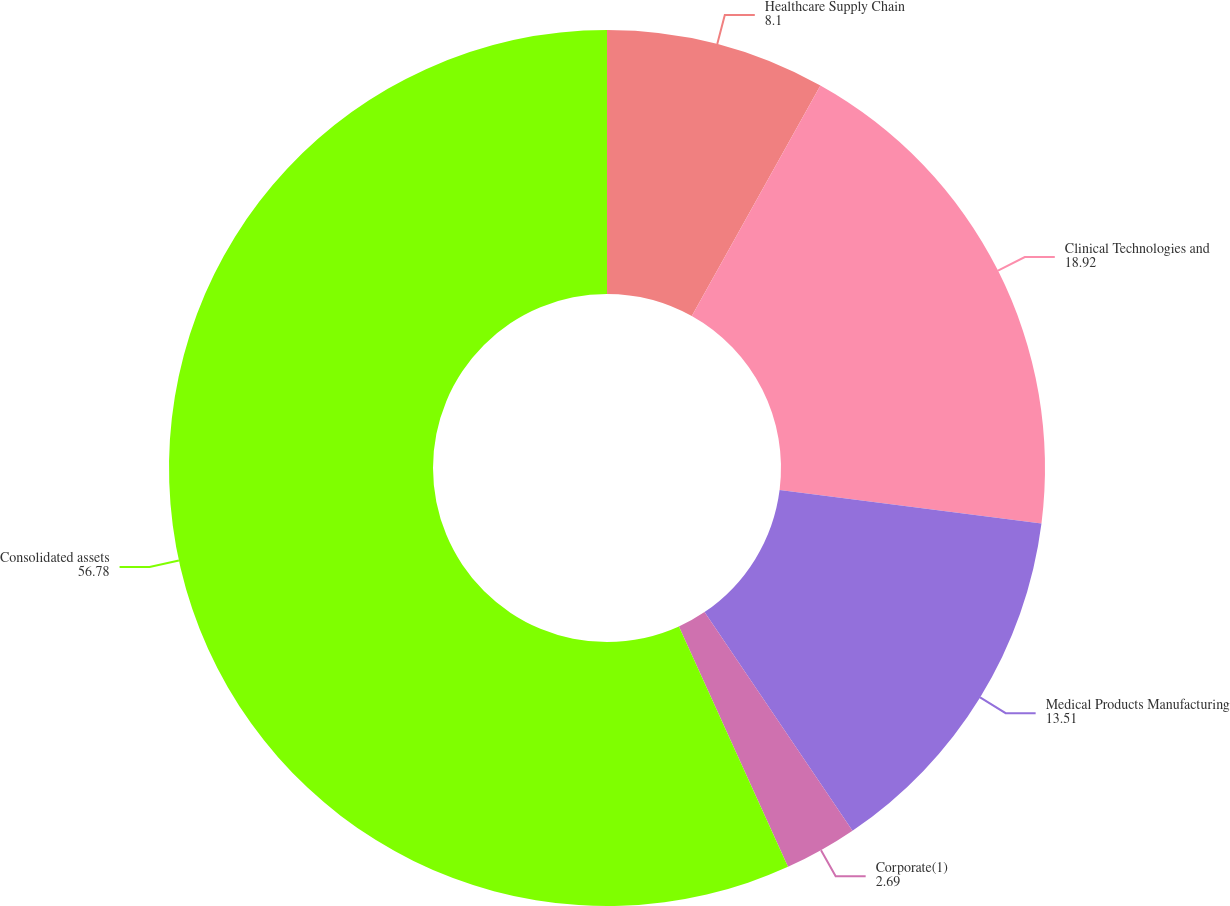<chart> <loc_0><loc_0><loc_500><loc_500><pie_chart><fcel>Healthcare Supply Chain<fcel>Clinical Technologies and<fcel>Medical Products Manufacturing<fcel>Corporate(1)<fcel>Consolidated assets<nl><fcel>8.1%<fcel>18.92%<fcel>13.51%<fcel>2.69%<fcel>56.78%<nl></chart> 